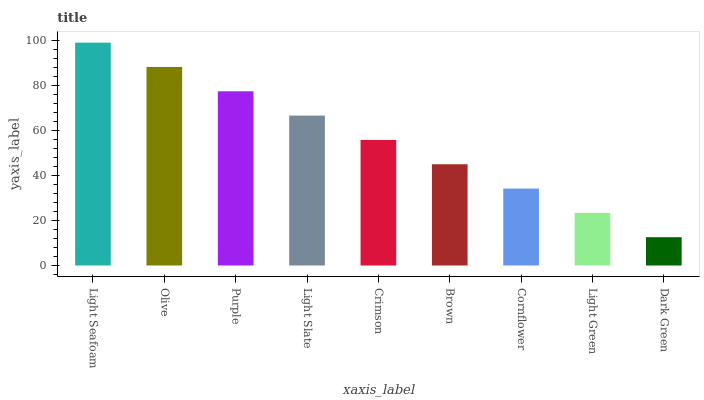Is Dark Green the minimum?
Answer yes or no. Yes. Is Light Seafoam the maximum?
Answer yes or no. Yes. Is Olive the minimum?
Answer yes or no. No. Is Olive the maximum?
Answer yes or no. No. Is Light Seafoam greater than Olive?
Answer yes or no. Yes. Is Olive less than Light Seafoam?
Answer yes or no. Yes. Is Olive greater than Light Seafoam?
Answer yes or no. No. Is Light Seafoam less than Olive?
Answer yes or no. No. Is Crimson the high median?
Answer yes or no. Yes. Is Crimson the low median?
Answer yes or no. Yes. Is Purple the high median?
Answer yes or no. No. Is Olive the low median?
Answer yes or no. No. 